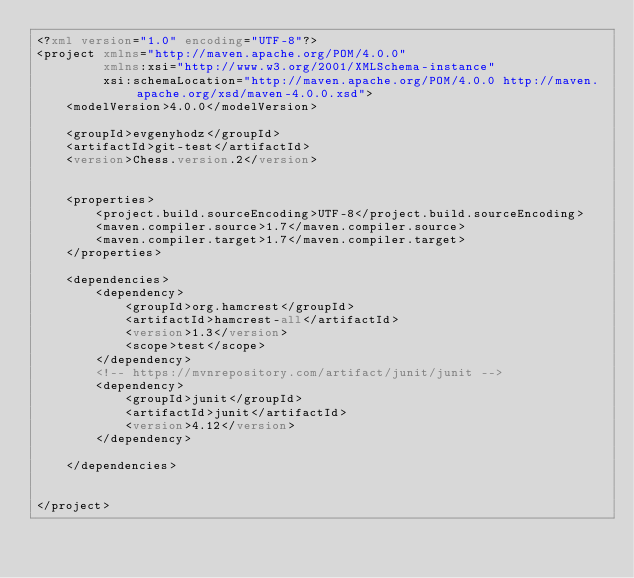Convert code to text. <code><loc_0><loc_0><loc_500><loc_500><_XML_><?xml version="1.0" encoding="UTF-8"?>
<project xmlns="http://maven.apache.org/POM/4.0.0"
         xmlns:xsi="http://www.w3.org/2001/XMLSchema-instance"
         xsi:schemaLocation="http://maven.apache.org/POM/4.0.0 http://maven.apache.org/xsd/maven-4.0.0.xsd">
    <modelVersion>4.0.0</modelVersion>

    <groupId>evgenyhodz</groupId>
    <artifactId>git-test</artifactId>
    <version>Chess.version.2</version>


    <properties>
        <project.build.sourceEncoding>UTF-8</project.build.sourceEncoding>
        <maven.compiler.source>1.7</maven.compiler.source>
        <maven.compiler.target>1.7</maven.compiler.target>
    </properties>

    <dependencies>
        <dependency>
            <groupId>org.hamcrest</groupId>
            <artifactId>hamcrest-all</artifactId>
            <version>1.3</version>
            <scope>test</scope>
        </dependency>
        <!-- https://mvnrepository.com/artifact/junit/junit -->
        <dependency>
            <groupId>junit</groupId>
            <artifactId>junit</artifactId>
            <version>4.12</version>
        </dependency>

    </dependencies>


</project></code> 